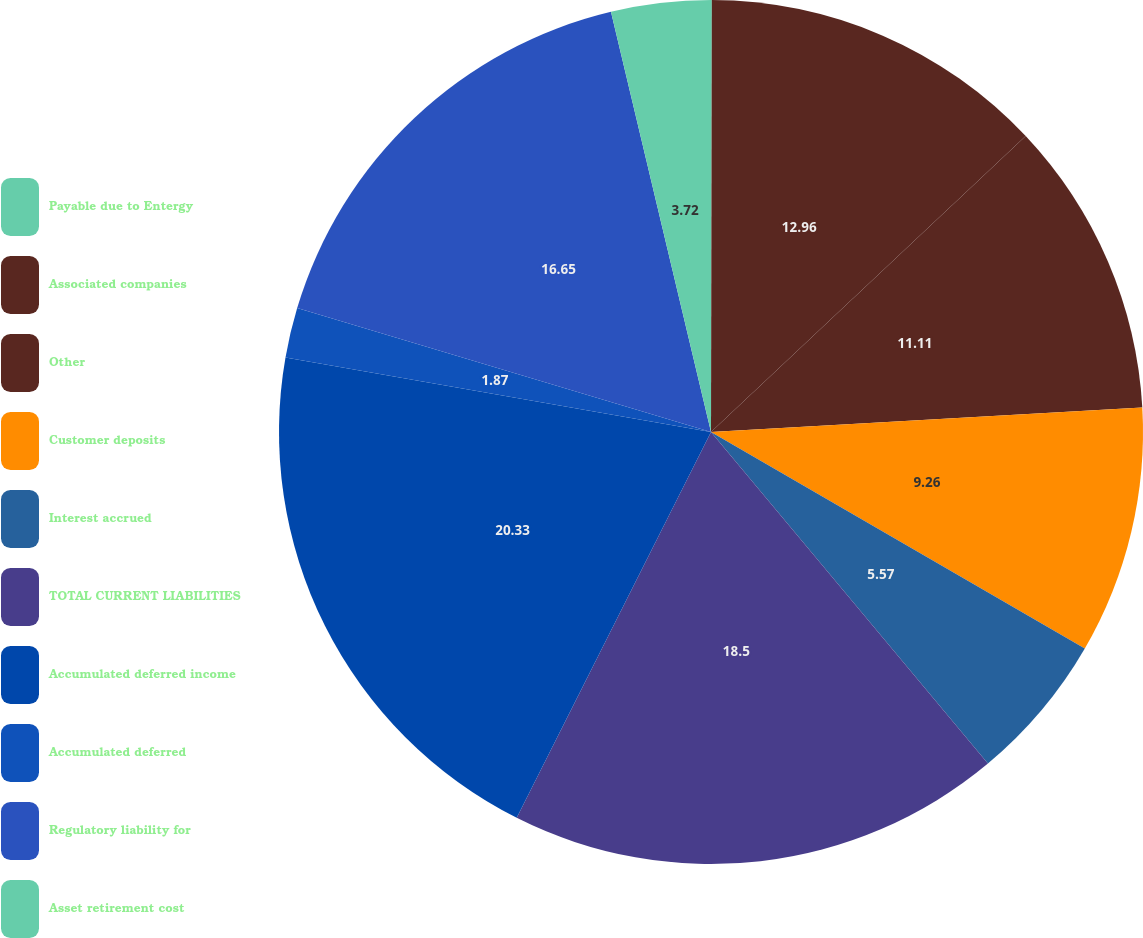Convert chart to OTSL. <chart><loc_0><loc_0><loc_500><loc_500><pie_chart><fcel>Payable due to Entergy<fcel>Associated companies<fcel>Other<fcel>Customer deposits<fcel>Interest accrued<fcel>TOTAL CURRENT LIABILITIES<fcel>Accumulated deferred income<fcel>Accumulated deferred<fcel>Regulatory liability for<fcel>Asset retirement cost<nl><fcel>0.03%<fcel>12.96%<fcel>11.11%<fcel>9.26%<fcel>5.57%<fcel>18.5%<fcel>20.34%<fcel>1.87%<fcel>16.65%<fcel>3.72%<nl></chart> 